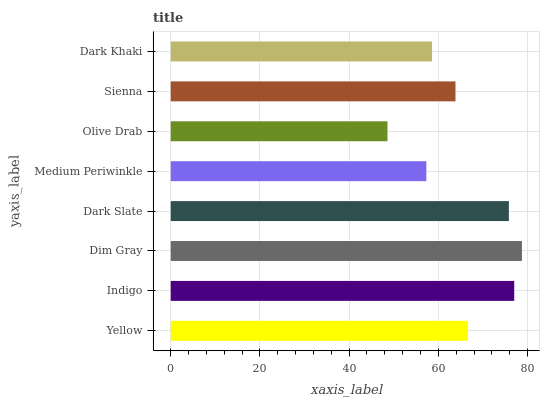Is Olive Drab the minimum?
Answer yes or no. Yes. Is Dim Gray the maximum?
Answer yes or no. Yes. Is Indigo the minimum?
Answer yes or no. No. Is Indigo the maximum?
Answer yes or no. No. Is Indigo greater than Yellow?
Answer yes or no. Yes. Is Yellow less than Indigo?
Answer yes or no. Yes. Is Yellow greater than Indigo?
Answer yes or no. No. Is Indigo less than Yellow?
Answer yes or no. No. Is Yellow the high median?
Answer yes or no. Yes. Is Sienna the low median?
Answer yes or no. Yes. Is Dark Khaki the high median?
Answer yes or no. No. Is Dark Slate the low median?
Answer yes or no. No. 